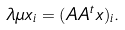<formula> <loc_0><loc_0><loc_500><loc_500>\lambda \mu x _ { i } = ( { A A ^ { t } } { x } ) _ { i } .</formula> 